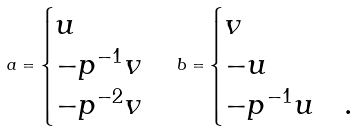<formula> <loc_0><loc_0><loc_500><loc_500>a = \begin{cases} u & \\ - p ^ { - 1 } v & \\ - p ^ { - 2 } v & \end{cases} b = \begin{cases} v & \\ - u & \\ - p ^ { - 1 } u & . \end{cases}</formula> 